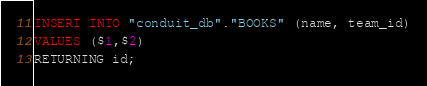Convert code to text. <code><loc_0><loc_0><loc_500><loc_500><_SQL_>INSERT INTO "conduit_db"."BOOKS" (name, team_id)
VALUES ($1,$2)
RETURNING id;</code> 